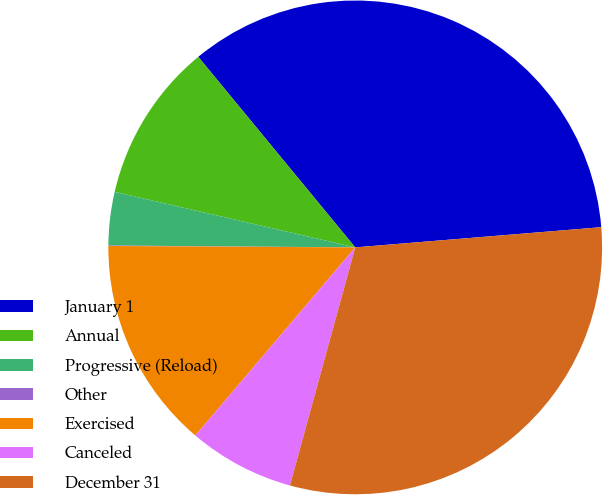Convert chart to OTSL. <chart><loc_0><loc_0><loc_500><loc_500><pie_chart><fcel>January 1<fcel>Annual<fcel>Progressive (Reload)<fcel>Other<fcel>Exercised<fcel>Canceled<fcel>December 31<nl><fcel>34.66%<fcel>10.42%<fcel>3.49%<fcel>0.03%<fcel>13.88%<fcel>6.95%<fcel>30.56%<nl></chart> 